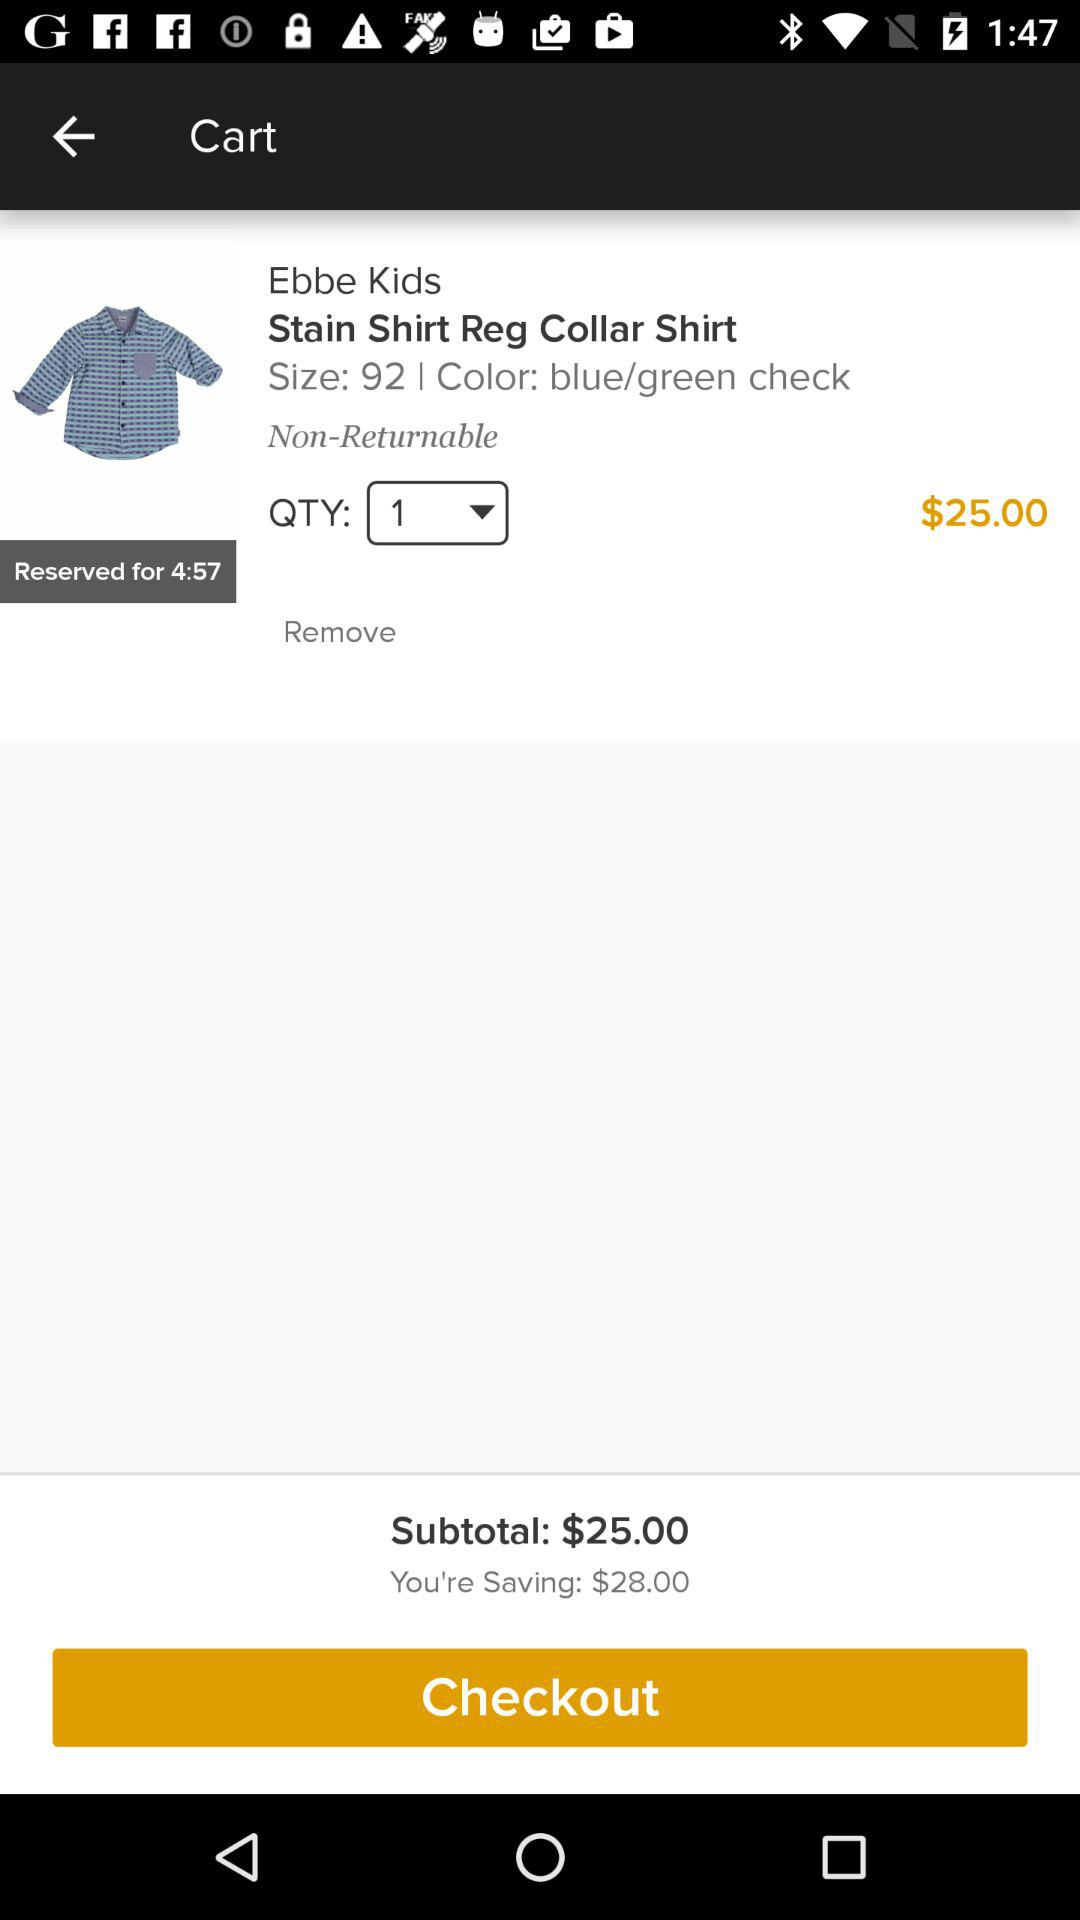What's the price of the shirt? The price of the shirt is 25 dollars. 